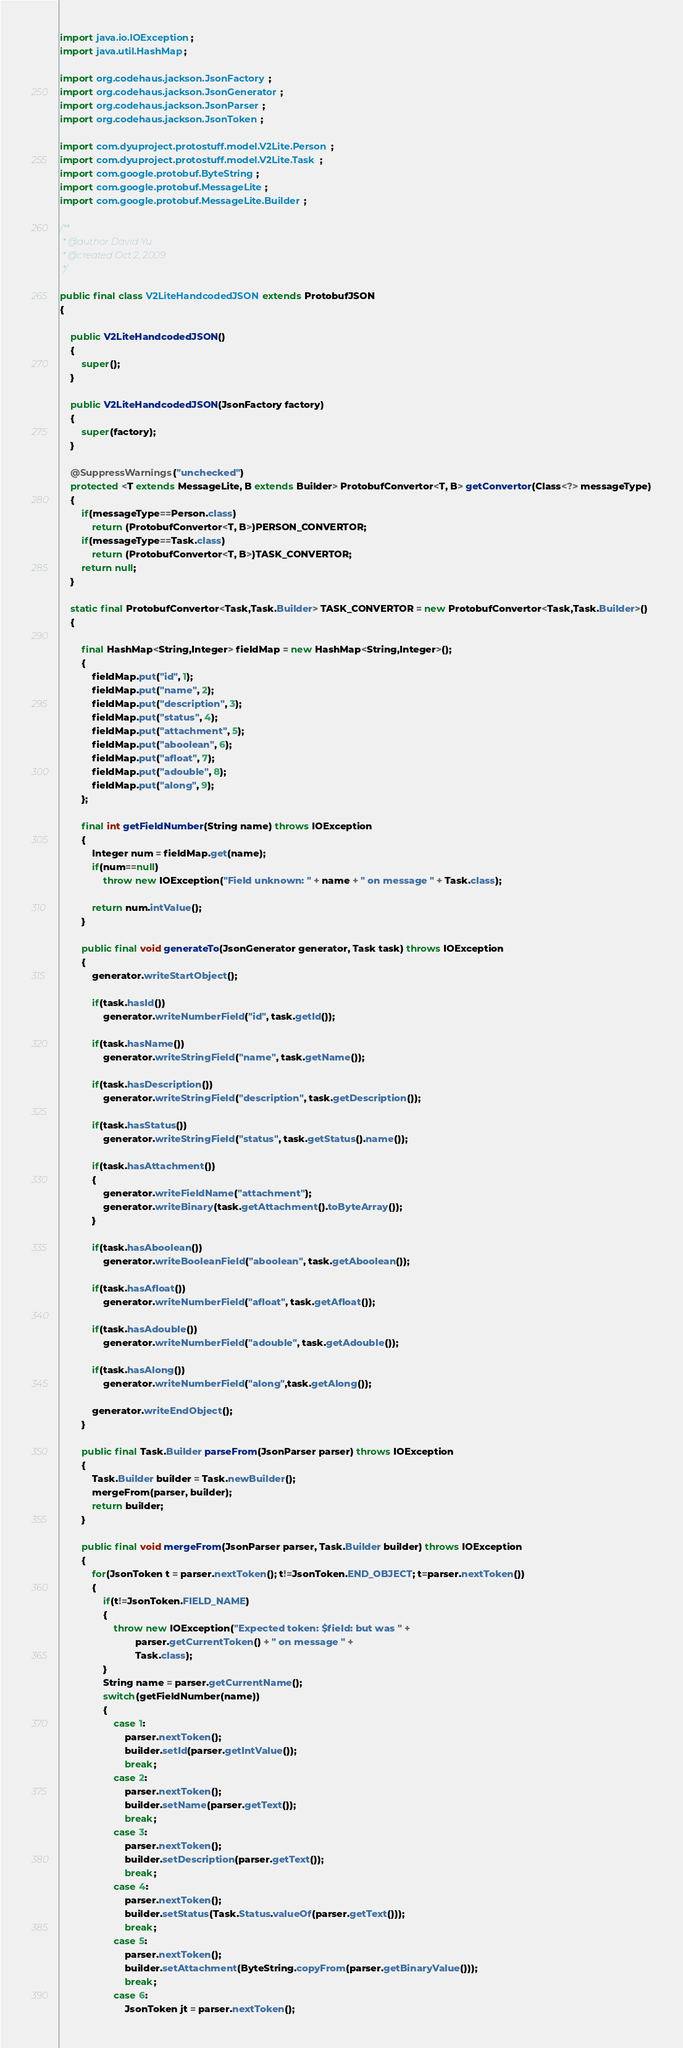Convert code to text. <code><loc_0><loc_0><loc_500><loc_500><_Java_>
import java.io.IOException;
import java.util.HashMap;

import org.codehaus.jackson.JsonFactory;
import org.codehaus.jackson.JsonGenerator;
import org.codehaus.jackson.JsonParser;
import org.codehaus.jackson.JsonToken;

import com.dyuproject.protostuff.model.V2Lite.Person;
import com.dyuproject.protostuff.model.V2Lite.Task;
import com.google.protobuf.ByteString;
import com.google.protobuf.MessageLite;
import com.google.protobuf.MessageLite.Builder;

/**
 * @author David Yu
 * @created Oct 2, 2009
 */

public final class V2LiteHandcodedJSON extends ProtobufJSON
{
    
    public V2LiteHandcodedJSON()
    {
        super();
    }
    
    public V2LiteHandcodedJSON(JsonFactory factory)
    {
        super(factory);
    }
    
    @SuppressWarnings("unchecked")
    protected <T extends MessageLite, B extends Builder> ProtobufConvertor<T, B> getConvertor(Class<?> messageType)
    {
        if(messageType==Person.class)
            return (ProtobufConvertor<T, B>)PERSON_CONVERTOR;
        if(messageType==Task.class)
            return (ProtobufConvertor<T, B>)TASK_CONVERTOR;
        return null;
    }
    
    static final ProtobufConvertor<Task,Task.Builder> TASK_CONVERTOR = new ProtobufConvertor<Task,Task.Builder>()
    {
        
        final HashMap<String,Integer> fieldMap = new HashMap<String,Integer>();
        {
            fieldMap.put("id", 1);
            fieldMap.put("name", 2);
            fieldMap.put("description", 3);
            fieldMap.put("status", 4);
            fieldMap.put("attachment", 5);
            fieldMap.put("aboolean", 6);
            fieldMap.put("afloat", 7);
            fieldMap.put("adouble", 8);
            fieldMap.put("along", 9);
        };
        
        final int getFieldNumber(String name) throws IOException
        {
            Integer num = fieldMap.get(name);
            if(num==null)
                throw new IOException("Field unknown: " + name + " on message " + Task.class);
            
            return num.intValue();
        }

        public final void generateTo(JsonGenerator generator, Task task) throws IOException
        {
            generator.writeStartObject();
            
            if(task.hasId())
                generator.writeNumberField("id", task.getId());
            
            if(task.hasName())
                generator.writeStringField("name", task.getName());
            
            if(task.hasDescription())
                generator.writeStringField("description", task.getDescription());
            
            if(task.hasStatus())
                generator.writeStringField("status", task.getStatus().name());
            
            if(task.hasAttachment())
            {
                generator.writeFieldName("attachment");
                generator.writeBinary(task.getAttachment().toByteArray());
            }
            
            if(task.hasAboolean())
                generator.writeBooleanField("aboolean", task.getAboolean());
            
            if(task.hasAfloat())
                generator.writeNumberField("afloat", task.getAfloat());
            
            if(task.hasAdouble())
                generator.writeNumberField("adouble", task.getAdouble());
            
            if(task.hasAlong())
                generator.writeNumberField("along",task.getAlong());
            
            generator.writeEndObject();            
        }

        public final Task.Builder parseFrom(JsonParser parser) throws IOException
        {
            Task.Builder builder = Task.newBuilder();
            mergeFrom(parser, builder);
            return builder;
        }

        public final void mergeFrom(JsonParser parser, Task.Builder builder) throws IOException
        {
            for(JsonToken t = parser.nextToken(); t!=JsonToken.END_OBJECT; t=parser.nextToken())
            {
                if(t!=JsonToken.FIELD_NAME)
                {
                    throw new IOException("Expected token: $field: but was " + 
                            parser.getCurrentToken() + " on message " + 
                            Task.class);
                }
                String name = parser.getCurrentName();
                switch(getFieldNumber(name))
                {
                    case 1:
                        parser.nextToken();
                        builder.setId(parser.getIntValue());
                        break;
                    case 2:
                        parser.nextToken();
                        builder.setName(parser.getText());
                        break;
                    case 3:
                        parser.nextToken();
                        builder.setDescription(parser.getText());
                        break;
                    case 4:
                        parser.nextToken();
                        builder.setStatus(Task.Status.valueOf(parser.getText()));
                        break;
                    case 5:
                        parser.nextToken();
                        builder.setAttachment(ByteString.copyFrom(parser.getBinaryValue()));
                        break;
                    case 6:
                        JsonToken jt = parser.nextToken();</code> 